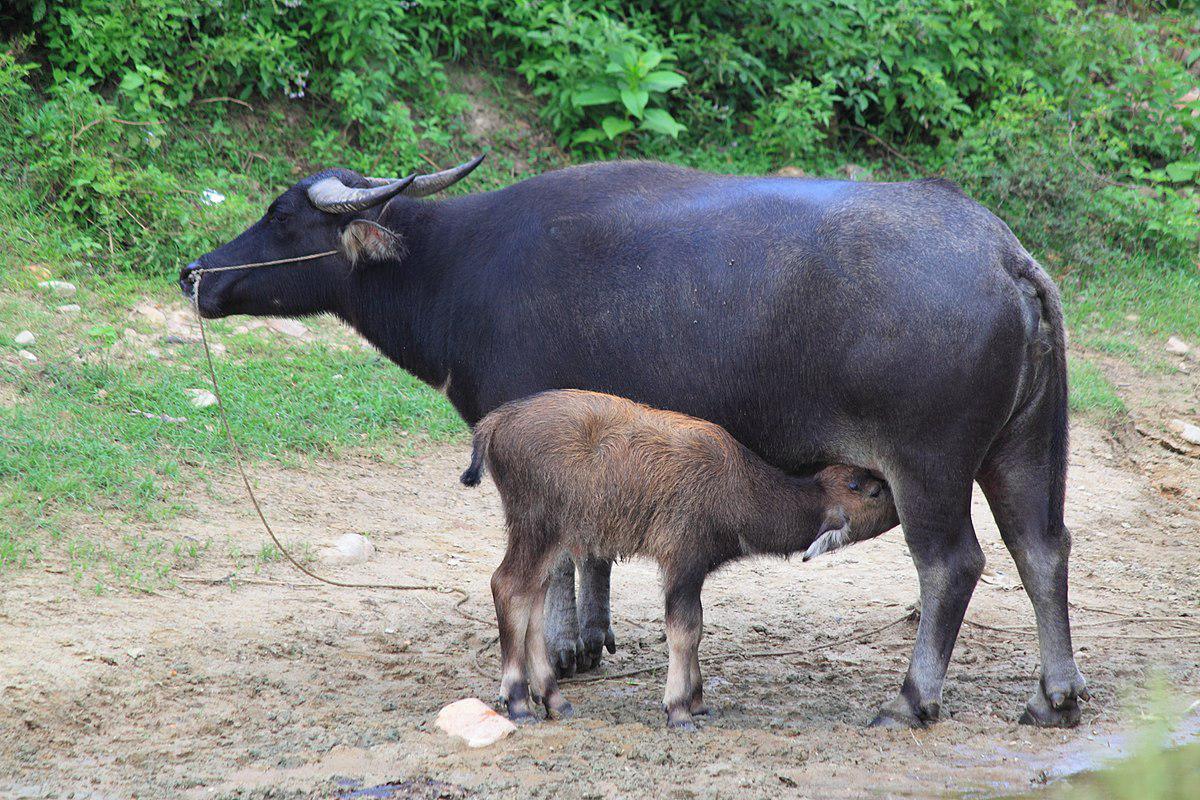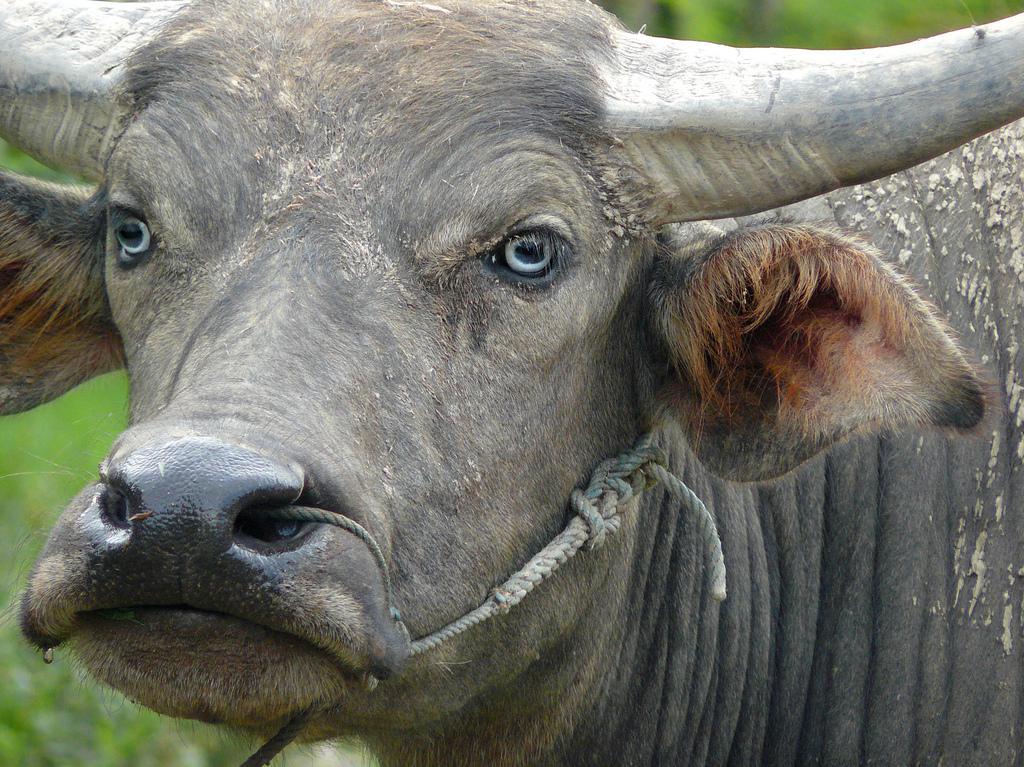The first image is the image on the left, the second image is the image on the right. For the images shown, is this caption "One image shows just one ox, and it has rope threaded through its nose." true? Answer yes or no. Yes. 